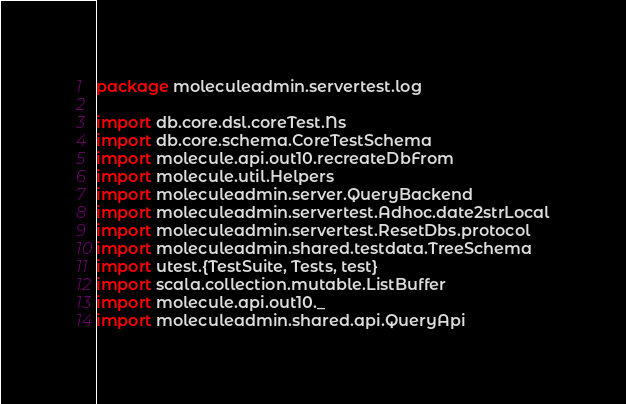Convert code to text. <code><loc_0><loc_0><loc_500><loc_500><_Scala_>package moleculeadmin.servertest.log

import db.core.dsl.coreTest.Ns
import db.core.schema.CoreTestSchema
import molecule.api.out10.recreateDbFrom
import molecule.util.Helpers
import moleculeadmin.server.QueryBackend
import moleculeadmin.servertest.Adhoc.date2strLocal
import moleculeadmin.servertest.ResetDbs.protocol
import moleculeadmin.shared.testdata.TreeSchema
import utest.{TestSuite, Tests, test}
import scala.collection.mutable.ListBuffer
import molecule.api.out10._
import moleculeadmin.shared.api.QueryApi</code> 